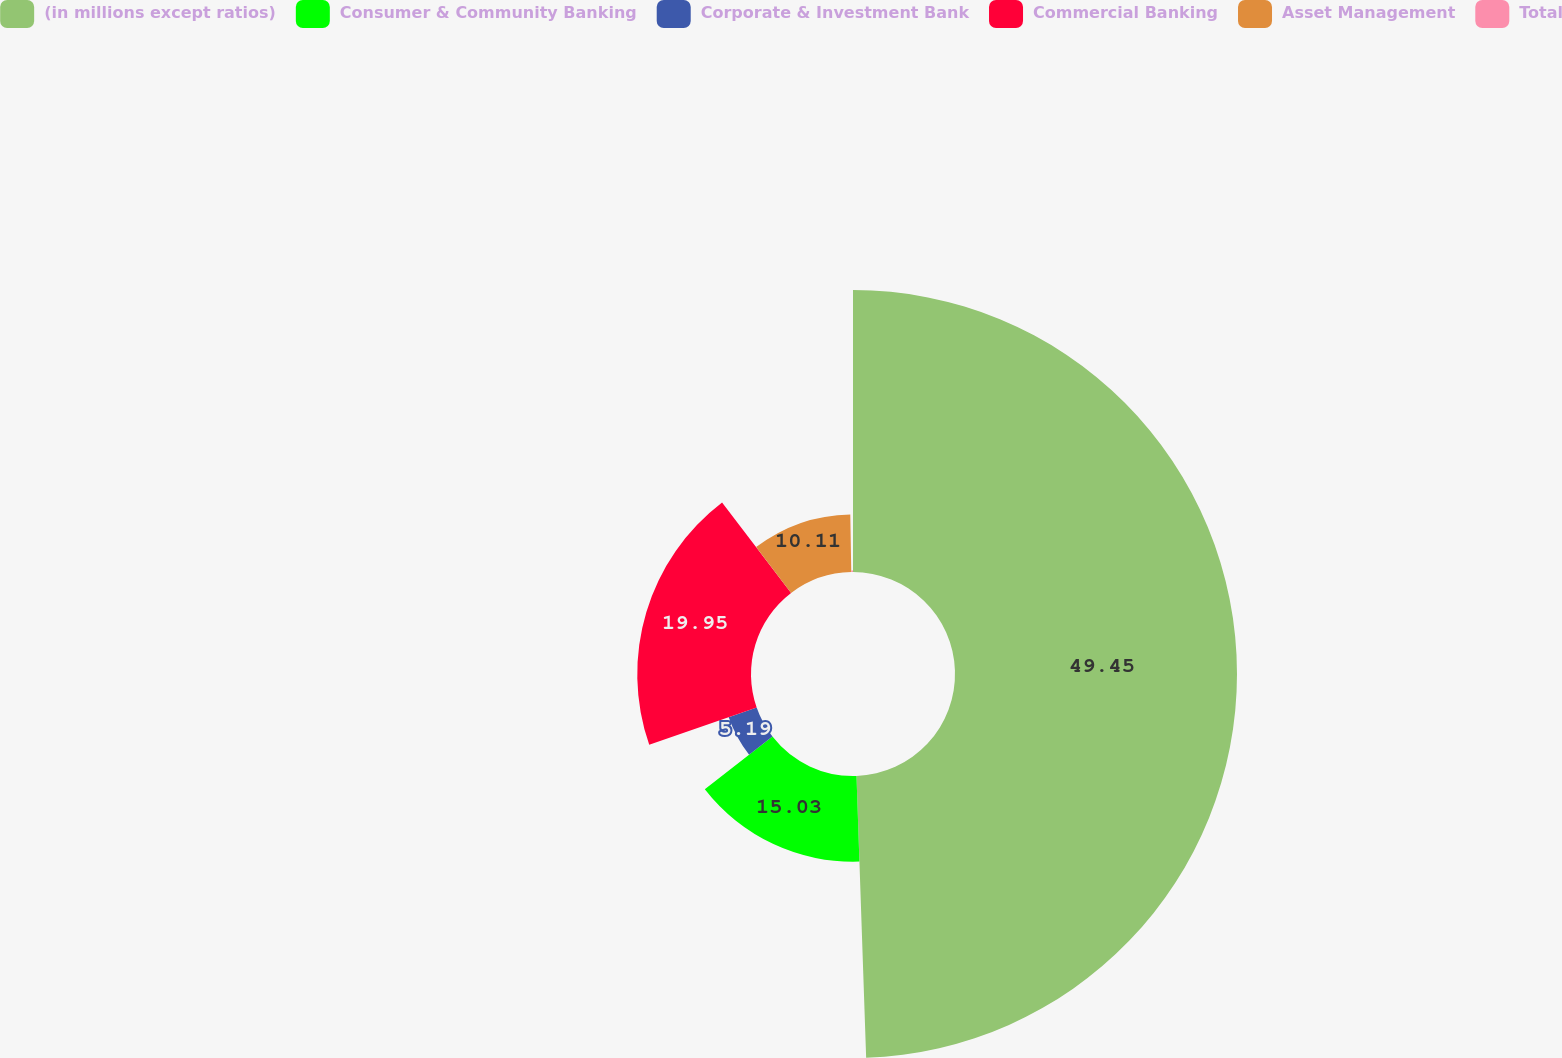Convert chart. <chart><loc_0><loc_0><loc_500><loc_500><pie_chart><fcel>(in millions except ratios)<fcel>Consumer & Community Banking<fcel>Corporate & Investment Bank<fcel>Commercial Banking<fcel>Asset Management<fcel>Total<nl><fcel>49.46%<fcel>15.03%<fcel>5.19%<fcel>19.95%<fcel>10.11%<fcel>0.27%<nl></chart> 